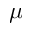<formula> <loc_0><loc_0><loc_500><loc_500>\mu</formula> 